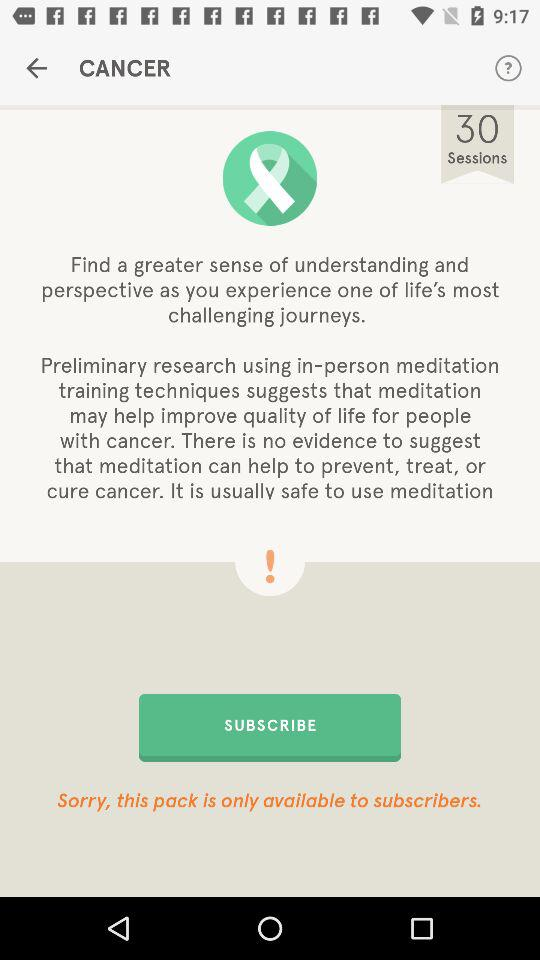What is the total number of sessions? The total number of sessions is 30. 